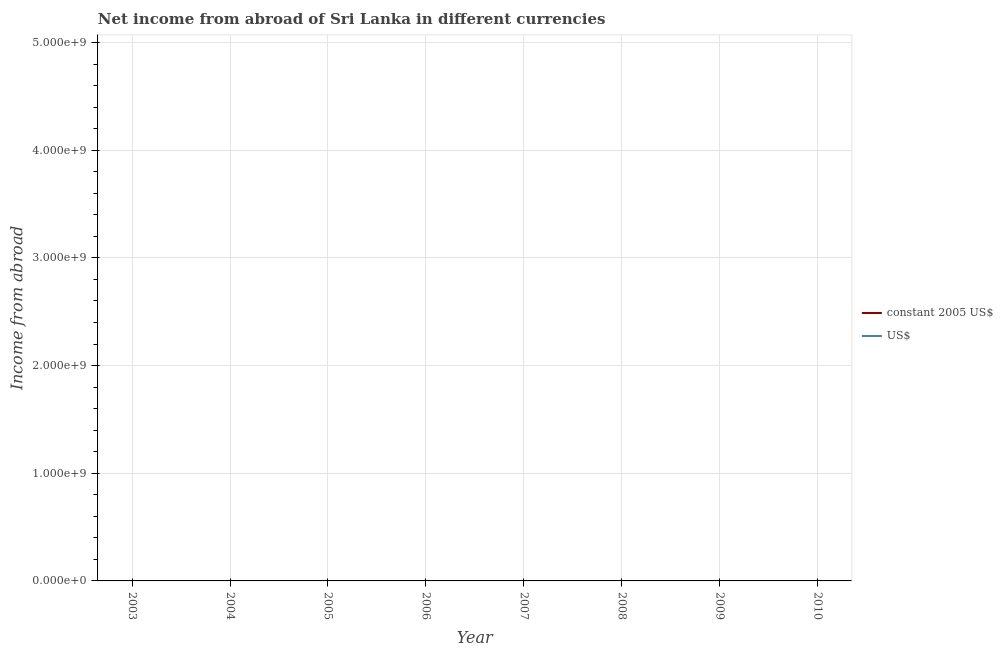Is the number of lines equal to the number of legend labels?
Your answer should be very brief. No. Across all years, what is the minimum income from abroad in constant 2005 us$?
Your answer should be compact. 0. Does the income from abroad in constant 2005 us$ monotonically increase over the years?
Your response must be concise. No. How many lines are there?
Your answer should be compact. 0. How many years are there in the graph?
Your answer should be compact. 8. Does the graph contain grids?
Your answer should be very brief. Yes. How many legend labels are there?
Make the answer very short. 2. What is the title of the graph?
Provide a short and direct response. Net income from abroad of Sri Lanka in different currencies. Does "Domestic liabilities" appear as one of the legend labels in the graph?
Offer a terse response. No. What is the label or title of the Y-axis?
Offer a very short reply. Income from abroad. What is the Income from abroad in US$ in 2005?
Offer a very short reply. 0. What is the Income from abroad in constant 2005 US$ in 2006?
Ensure brevity in your answer.  0. What is the Income from abroad in US$ in 2006?
Provide a short and direct response. 0. What is the Income from abroad of constant 2005 US$ in 2007?
Provide a succinct answer. 0. What is the Income from abroad of constant 2005 US$ in 2008?
Your answer should be very brief. 0. What is the Income from abroad in US$ in 2008?
Give a very brief answer. 0. What is the total Income from abroad in US$ in the graph?
Your response must be concise. 0. What is the average Income from abroad of constant 2005 US$ per year?
Your response must be concise. 0. 